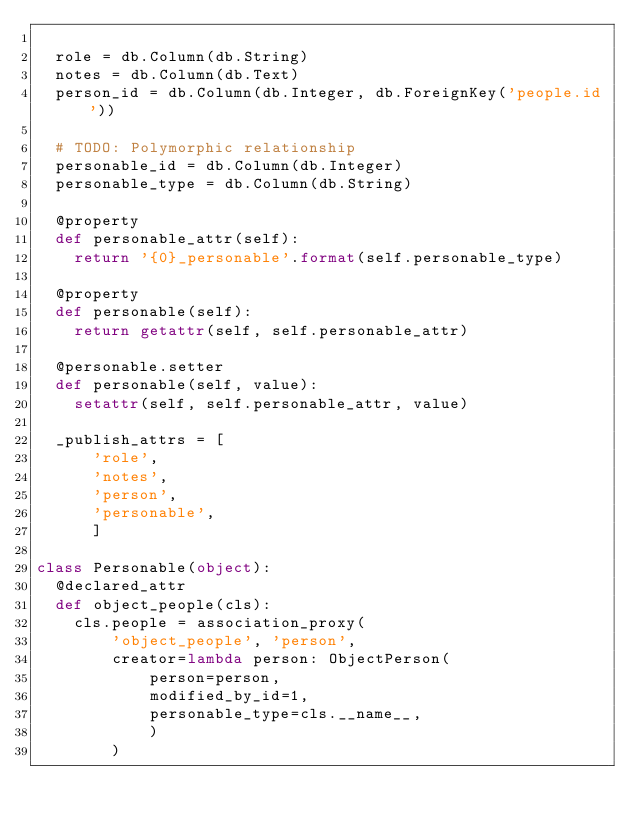<code> <loc_0><loc_0><loc_500><loc_500><_Python_>
  role = db.Column(db.String)
  notes = db.Column(db.Text)
  person_id = db.Column(db.Integer, db.ForeignKey('people.id'))

  # TODO: Polymorphic relationship
  personable_id = db.Column(db.Integer)
  personable_type = db.Column(db.String)

  @property
  def personable_attr(self):
    return '{0}_personable'.format(self.personable_type)

  @property
  def personable(self):
    return getattr(self, self.personable_attr)

  @personable.setter
  def personable(self, value):
    setattr(self, self.personable_attr, value)

  _publish_attrs = [
      'role',
      'notes',
      'person',
      'personable',
      ]

class Personable(object):
  @declared_attr
  def object_people(cls):
    cls.people = association_proxy(
        'object_people', 'person',
        creator=lambda person: ObjectPerson(
            person=person,
            modified_by_id=1,
            personable_type=cls.__name__,
            )
        )</code> 